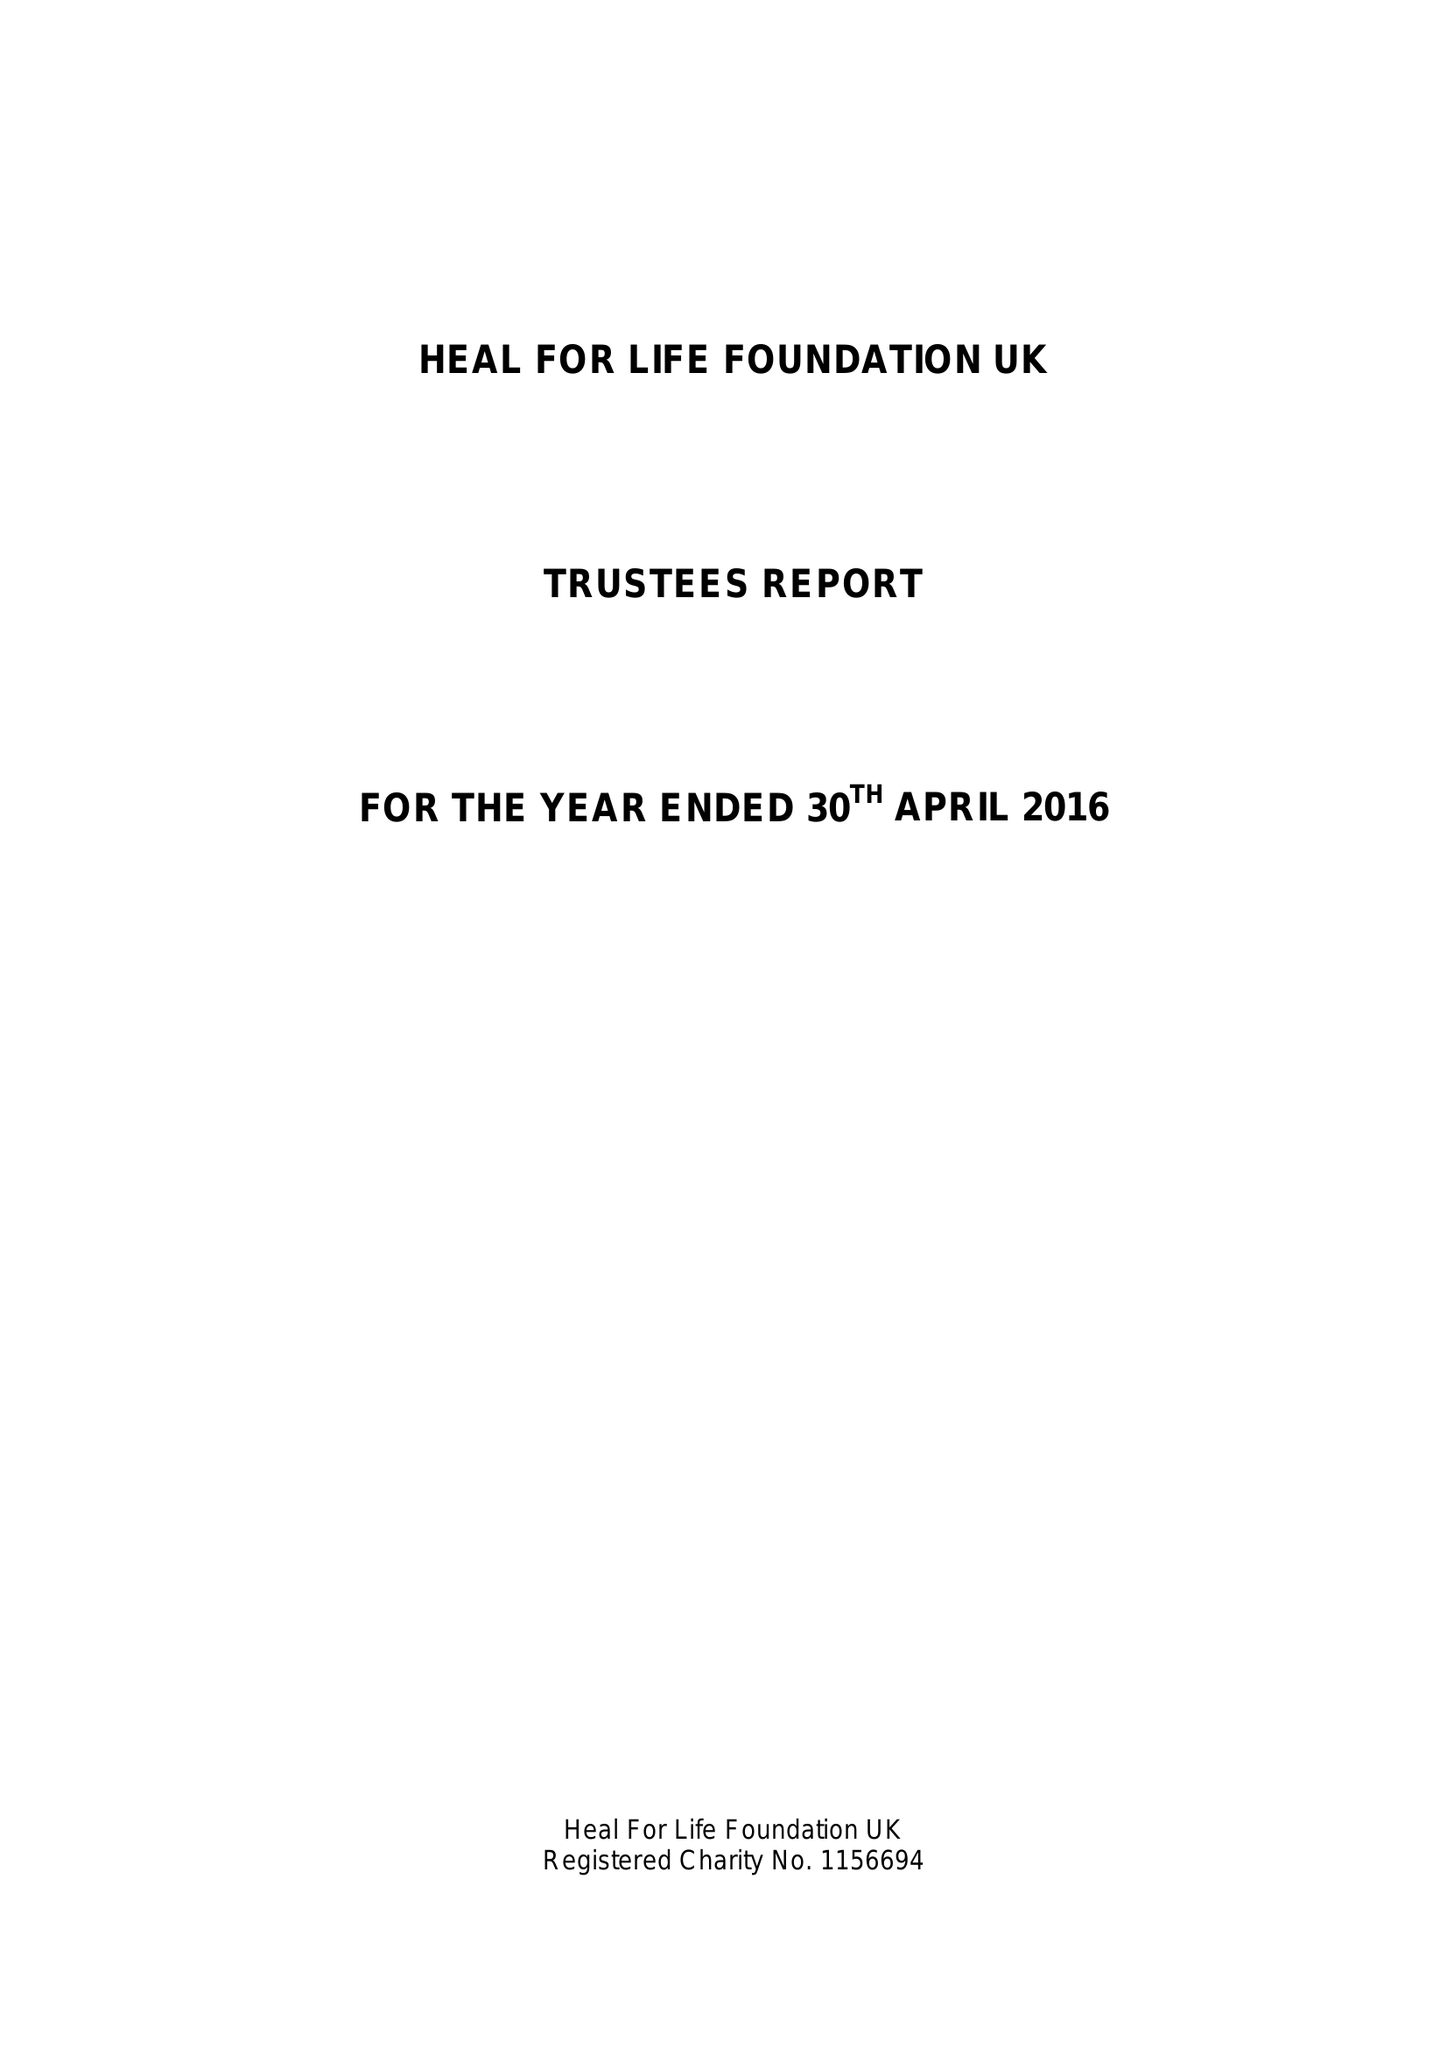What is the value for the charity_name?
Answer the question using a single word or phrase. Heal For Life Foundation Uk 